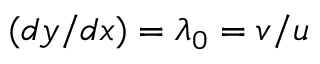Convert formula to latex. <formula><loc_0><loc_0><loc_500><loc_500>( d y / d x ) = \lambda _ { 0 } = v / u</formula> 